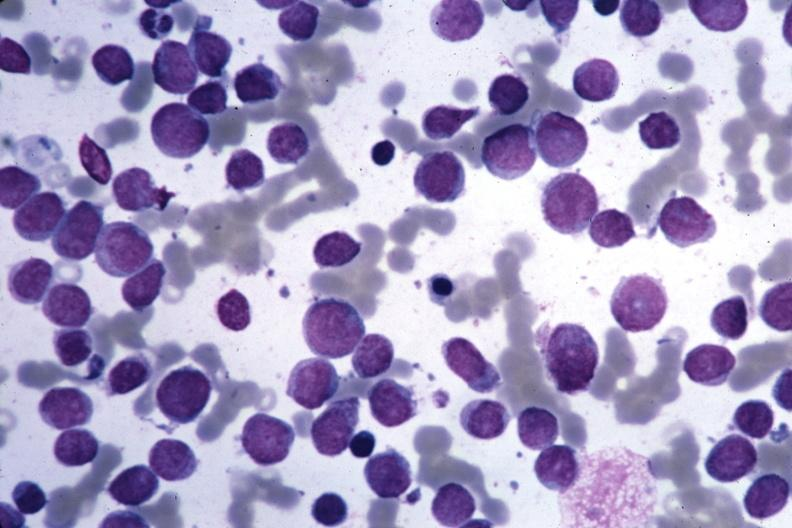does this image show wrights easily seen blastic cells?
Answer the question using a single word or phrase. Yes 